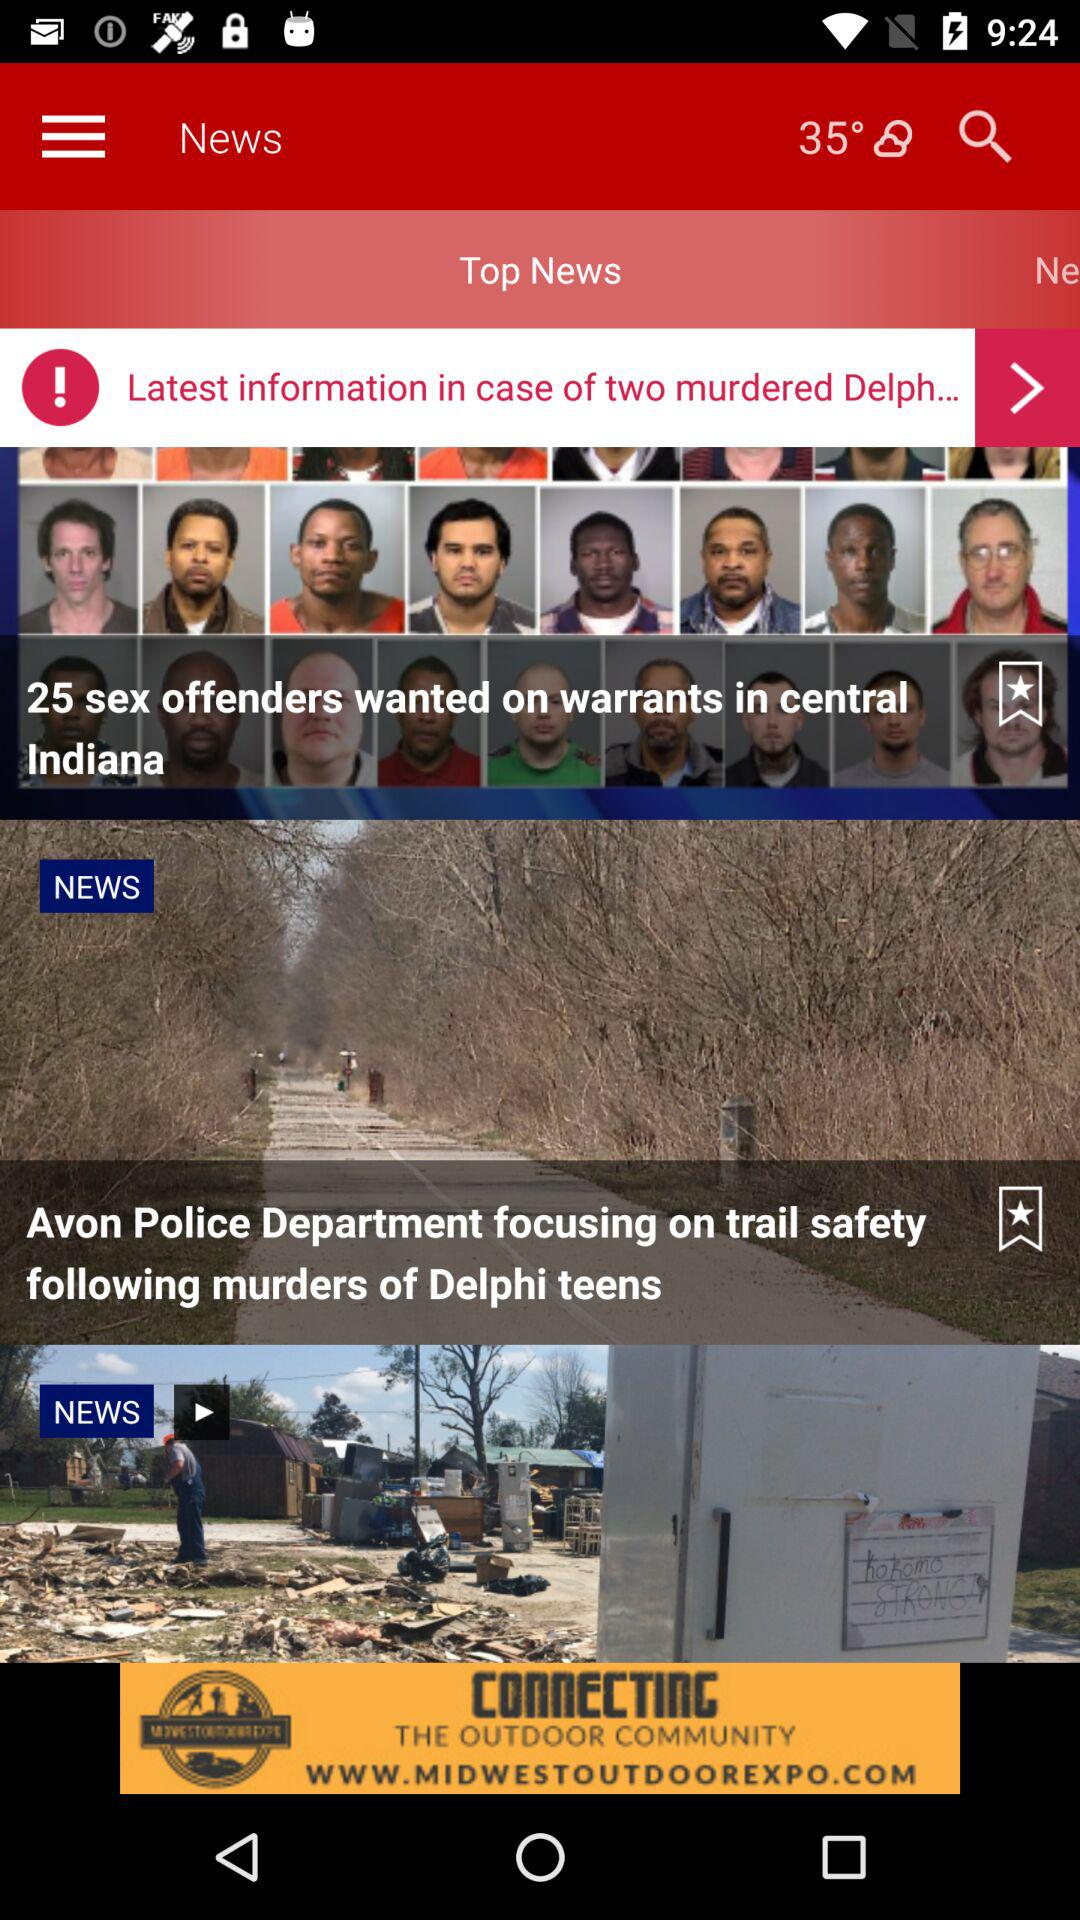How many sex offenders are wanted on warrants in Central Indiana? The sex offenders that are wanted on warrants in Central Indiana are 25. 